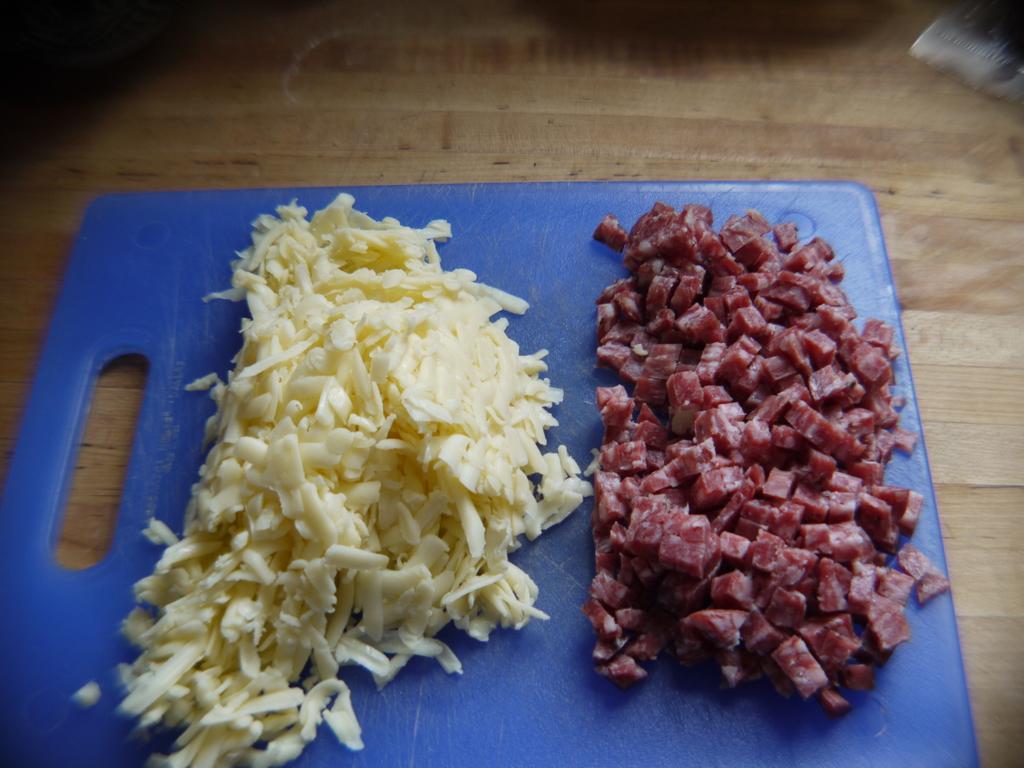How would you summarize this image in a sentence or two? In this image we can see some food item and meat are cut and kept on the blue color chop board which is placed on the wooden surface. 